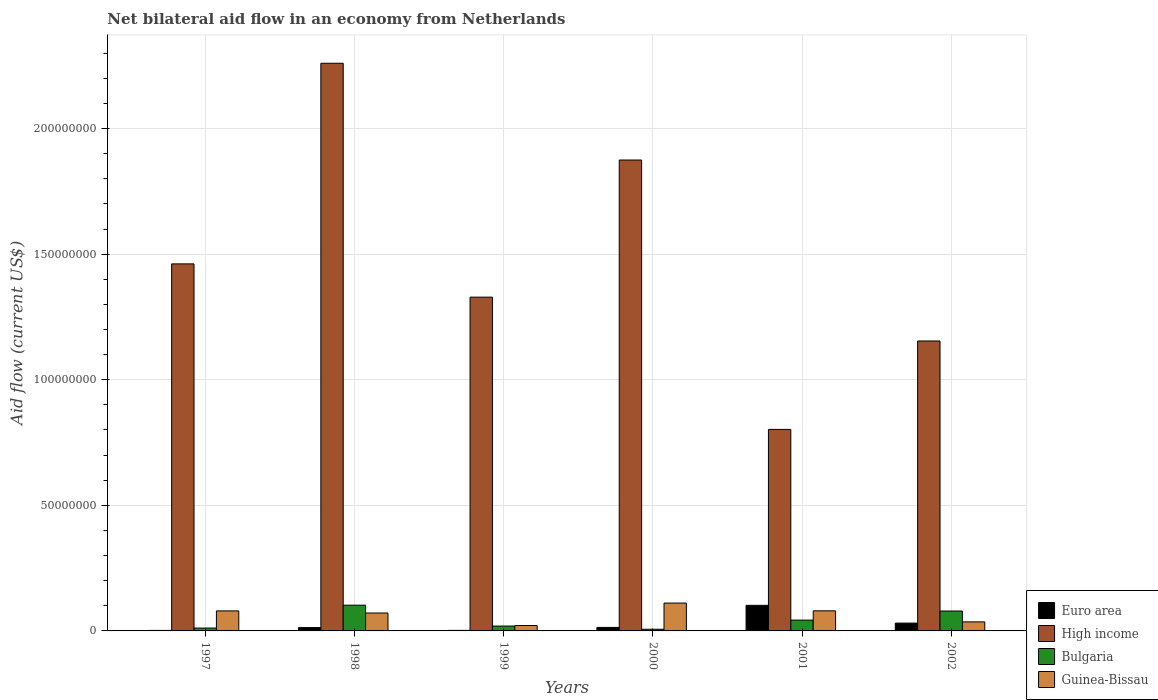How many different coloured bars are there?
Your answer should be compact. 4. How many groups of bars are there?
Provide a short and direct response. 6. Are the number of bars on each tick of the X-axis equal?
Your answer should be compact. Yes. What is the net bilateral aid flow in Bulgaria in 1997?
Your response must be concise. 1.14e+06. Across all years, what is the maximum net bilateral aid flow in Euro area?
Ensure brevity in your answer.  1.02e+07. Across all years, what is the minimum net bilateral aid flow in Euro area?
Your answer should be compact. 2.10e+05. In which year was the net bilateral aid flow in High income maximum?
Keep it short and to the point. 1998. In which year was the net bilateral aid flow in Bulgaria minimum?
Your response must be concise. 2000. What is the total net bilateral aid flow in Guinea-Bissau in the graph?
Provide a succinct answer. 3.99e+07. What is the difference between the net bilateral aid flow in Euro area in 1997 and that in 2001?
Provide a short and direct response. -9.98e+06. What is the difference between the net bilateral aid flow in Bulgaria in 1998 and the net bilateral aid flow in High income in 2002?
Give a very brief answer. -1.05e+08. What is the average net bilateral aid flow in Bulgaria per year?
Offer a terse response. 4.37e+06. In the year 2002, what is the difference between the net bilateral aid flow in Bulgaria and net bilateral aid flow in Euro area?
Make the answer very short. 4.81e+06. What is the ratio of the net bilateral aid flow in High income in 1998 to that in 2002?
Your response must be concise. 1.96. Is the net bilateral aid flow in Bulgaria in 1997 less than that in 2001?
Make the answer very short. Yes. What is the difference between the highest and the second highest net bilateral aid flow in Euro area?
Give a very brief answer. 7.08e+06. What is the difference between the highest and the lowest net bilateral aid flow in High income?
Make the answer very short. 1.46e+08. Is it the case that in every year, the sum of the net bilateral aid flow in Guinea-Bissau and net bilateral aid flow in High income is greater than the net bilateral aid flow in Euro area?
Provide a succinct answer. Yes. Are all the bars in the graph horizontal?
Provide a succinct answer. No. How many years are there in the graph?
Make the answer very short. 6. What is the difference between two consecutive major ticks on the Y-axis?
Your answer should be very brief. 5.00e+07. Does the graph contain any zero values?
Your answer should be very brief. No. How are the legend labels stacked?
Give a very brief answer. Vertical. What is the title of the graph?
Provide a short and direct response. Net bilateral aid flow in an economy from Netherlands. Does "Euro area" appear as one of the legend labels in the graph?
Your answer should be very brief. Yes. What is the label or title of the Y-axis?
Your answer should be compact. Aid flow (current US$). What is the Aid flow (current US$) of High income in 1997?
Your answer should be very brief. 1.46e+08. What is the Aid flow (current US$) of Bulgaria in 1997?
Provide a succinct answer. 1.14e+06. What is the Aid flow (current US$) of Guinea-Bissau in 1997?
Offer a terse response. 7.97e+06. What is the Aid flow (current US$) in Euro area in 1998?
Your answer should be compact. 1.33e+06. What is the Aid flow (current US$) of High income in 1998?
Offer a very short reply. 2.26e+08. What is the Aid flow (current US$) in Bulgaria in 1998?
Offer a terse response. 1.02e+07. What is the Aid flow (current US$) in Guinea-Bissau in 1998?
Provide a short and direct response. 7.13e+06. What is the Aid flow (current US$) of Euro area in 1999?
Your response must be concise. 2.20e+05. What is the Aid flow (current US$) in High income in 1999?
Your response must be concise. 1.33e+08. What is the Aid flow (current US$) in Bulgaria in 1999?
Your answer should be compact. 1.94e+06. What is the Aid flow (current US$) in Guinea-Bissau in 1999?
Ensure brevity in your answer.  2.15e+06. What is the Aid flow (current US$) in Euro area in 2000?
Your answer should be very brief. 1.40e+06. What is the Aid flow (current US$) in High income in 2000?
Make the answer very short. 1.87e+08. What is the Aid flow (current US$) of Bulgaria in 2000?
Provide a succinct answer. 6.70e+05. What is the Aid flow (current US$) of Guinea-Bissau in 2000?
Give a very brief answer. 1.11e+07. What is the Aid flow (current US$) of Euro area in 2001?
Give a very brief answer. 1.02e+07. What is the Aid flow (current US$) of High income in 2001?
Provide a short and direct response. 8.02e+07. What is the Aid flow (current US$) in Bulgaria in 2001?
Provide a short and direct response. 4.31e+06. What is the Aid flow (current US$) in Euro area in 2002?
Offer a terse response. 3.11e+06. What is the Aid flow (current US$) in High income in 2002?
Ensure brevity in your answer.  1.15e+08. What is the Aid flow (current US$) in Bulgaria in 2002?
Your answer should be compact. 7.92e+06. What is the Aid flow (current US$) in Guinea-Bissau in 2002?
Your answer should be very brief. 3.60e+06. Across all years, what is the maximum Aid flow (current US$) in Euro area?
Your answer should be compact. 1.02e+07. Across all years, what is the maximum Aid flow (current US$) in High income?
Give a very brief answer. 2.26e+08. Across all years, what is the maximum Aid flow (current US$) of Bulgaria?
Offer a very short reply. 1.02e+07. Across all years, what is the maximum Aid flow (current US$) of Guinea-Bissau?
Ensure brevity in your answer.  1.11e+07. Across all years, what is the minimum Aid flow (current US$) of Euro area?
Provide a short and direct response. 2.10e+05. Across all years, what is the minimum Aid flow (current US$) in High income?
Provide a short and direct response. 8.02e+07. Across all years, what is the minimum Aid flow (current US$) of Bulgaria?
Give a very brief answer. 6.70e+05. Across all years, what is the minimum Aid flow (current US$) of Guinea-Bissau?
Provide a short and direct response. 2.15e+06. What is the total Aid flow (current US$) in Euro area in the graph?
Offer a terse response. 1.65e+07. What is the total Aid flow (current US$) of High income in the graph?
Keep it short and to the point. 8.88e+08. What is the total Aid flow (current US$) in Bulgaria in the graph?
Make the answer very short. 2.62e+07. What is the total Aid flow (current US$) of Guinea-Bissau in the graph?
Keep it short and to the point. 3.99e+07. What is the difference between the Aid flow (current US$) in Euro area in 1997 and that in 1998?
Your response must be concise. -1.12e+06. What is the difference between the Aid flow (current US$) of High income in 1997 and that in 1998?
Your answer should be very brief. -7.99e+07. What is the difference between the Aid flow (current US$) in Bulgaria in 1997 and that in 1998?
Provide a succinct answer. -9.11e+06. What is the difference between the Aid flow (current US$) of Guinea-Bissau in 1997 and that in 1998?
Your answer should be compact. 8.40e+05. What is the difference between the Aid flow (current US$) in High income in 1997 and that in 1999?
Offer a terse response. 1.32e+07. What is the difference between the Aid flow (current US$) in Bulgaria in 1997 and that in 1999?
Ensure brevity in your answer.  -8.00e+05. What is the difference between the Aid flow (current US$) of Guinea-Bissau in 1997 and that in 1999?
Give a very brief answer. 5.82e+06. What is the difference between the Aid flow (current US$) of Euro area in 1997 and that in 2000?
Keep it short and to the point. -1.19e+06. What is the difference between the Aid flow (current US$) of High income in 1997 and that in 2000?
Your response must be concise. -4.14e+07. What is the difference between the Aid flow (current US$) in Guinea-Bissau in 1997 and that in 2000?
Offer a very short reply. -3.12e+06. What is the difference between the Aid flow (current US$) of Euro area in 1997 and that in 2001?
Ensure brevity in your answer.  -9.98e+06. What is the difference between the Aid flow (current US$) of High income in 1997 and that in 2001?
Your answer should be very brief. 6.59e+07. What is the difference between the Aid flow (current US$) in Bulgaria in 1997 and that in 2001?
Give a very brief answer. -3.17e+06. What is the difference between the Aid flow (current US$) of Euro area in 1997 and that in 2002?
Ensure brevity in your answer.  -2.90e+06. What is the difference between the Aid flow (current US$) of High income in 1997 and that in 2002?
Make the answer very short. 3.07e+07. What is the difference between the Aid flow (current US$) of Bulgaria in 1997 and that in 2002?
Your answer should be compact. -6.78e+06. What is the difference between the Aid flow (current US$) of Guinea-Bissau in 1997 and that in 2002?
Provide a succinct answer. 4.37e+06. What is the difference between the Aid flow (current US$) in Euro area in 1998 and that in 1999?
Provide a succinct answer. 1.11e+06. What is the difference between the Aid flow (current US$) in High income in 1998 and that in 1999?
Keep it short and to the point. 9.31e+07. What is the difference between the Aid flow (current US$) of Bulgaria in 1998 and that in 1999?
Your answer should be very brief. 8.31e+06. What is the difference between the Aid flow (current US$) in Guinea-Bissau in 1998 and that in 1999?
Your answer should be compact. 4.98e+06. What is the difference between the Aid flow (current US$) in Euro area in 1998 and that in 2000?
Keep it short and to the point. -7.00e+04. What is the difference between the Aid flow (current US$) in High income in 1998 and that in 2000?
Make the answer very short. 3.85e+07. What is the difference between the Aid flow (current US$) in Bulgaria in 1998 and that in 2000?
Provide a short and direct response. 9.58e+06. What is the difference between the Aid flow (current US$) of Guinea-Bissau in 1998 and that in 2000?
Your answer should be compact. -3.96e+06. What is the difference between the Aid flow (current US$) in Euro area in 1998 and that in 2001?
Your response must be concise. -8.86e+06. What is the difference between the Aid flow (current US$) in High income in 1998 and that in 2001?
Keep it short and to the point. 1.46e+08. What is the difference between the Aid flow (current US$) in Bulgaria in 1998 and that in 2001?
Your response must be concise. 5.94e+06. What is the difference between the Aid flow (current US$) in Guinea-Bissau in 1998 and that in 2001?
Offer a very short reply. -8.70e+05. What is the difference between the Aid flow (current US$) of Euro area in 1998 and that in 2002?
Offer a terse response. -1.78e+06. What is the difference between the Aid flow (current US$) in High income in 1998 and that in 2002?
Your response must be concise. 1.11e+08. What is the difference between the Aid flow (current US$) of Bulgaria in 1998 and that in 2002?
Provide a short and direct response. 2.33e+06. What is the difference between the Aid flow (current US$) in Guinea-Bissau in 1998 and that in 2002?
Keep it short and to the point. 3.53e+06. What is the difference between the Aid flow (current US$) in Euro area in 1999 and that in 2000?
Your answer should be very brief. -1.18e+06. What is the difference between the Aid flow (current US$) of High income in 1999 and that in 2000?
Your response must be concise. -5.46e+07. What is the difference between the Aid flow (current US$) of Bulgaria in 1999 and that in 2000?
Ensure brevity in your answer.  1.27e+06. What is the difference between the Aid flow (current US$) of Guinea-Bissau in 1999 and that in 2000?
Provide a succinct answer. -8.94e+06. What is the difference between the Aid flow (current US$) in Euro area in 1999 and that in 2001?
Your response must be concise. -9.97e+06. What is the difference between the Aid flow (current US$) of High income in 1999 and that in 2001?
Ensure brevity in your answer.  5.27e+07. What is the difference between the Aid flow (current US$) of Bulgaria in 1999 and that in 2001?
Provide a succinct answer. -2.37e+06. What is the difference between the Aid flow (current US$) of Guinea-Bissau in 1999 and that in 2001?
Give a very brief answer. -5.85e+06. What is the difference between the Aid flow (current US$) of Euro area in 1999 and that in 2002?
Ensure brevity in your answer.  -2.89e+06. What is the difference between the Aid flow (current US$) in High income in 1999 and that in 2002?
Offer a very short reply. 1.74e+07. What is the difference between the Aid flow (current US$) in Bulgaria in 1999 and that in 2002?
Make the answer very short. -5.98e+06. What is the difference between the Aid flow (current US$) of Guinea-Bissau in 1999 and that in 2002?
Give a very brief answer. -1.45e+06. What is the difference between the Aid flow (current US$) in Euro area in 2000 and that in 2001?
Offer a terse response. -8.79e+06. What is the difference between the Aid flow (current US$) in High income in 2000 and that in 2001?
Your answer should be compact. 1.07e+08. What is the difference between the Aid flow (current US$) in Bulgaria in 2000 and that in 2001?
Provide a short and direct response. -3.64e+06. What is the difference between the Aid flow (current US$) in Guinea-Bissau in 2000 and that in 2001?
Keep it short and to the point. 3.09e+06. What is the difference between the Aid flow (current US$) of Euro area in 2000 and that in 2002?
Your answer should be very brief. -1.71e+06. What is the difference between the Aid flow (current US$) in High income in 2000 and that in 2002?
Your answer should be compact. 7.20e+07. What is the difference between the Aid flow (current US$) in Bulgaria in 2000 and that in 2002?
Provide a short and direct response. -7.25e+06. What is the difference between the Aid flow (current US$) in Guinea-Bissau in 2000 and that in 2002?
Ensure brevity in your answer.  7.49e+06. What is the difference between the Aid flow (current US$) of Euro area in 2001 and that in 2002?
Keep it short and to the point. 7.08e+06. What is the difference between the Aid flow (current US$) of High income in 2001 and that in 2002?
Provide a short and direct response. -3.52e+07. What is the difference between the Aid flow (current US$) in Bulgaria in 2001 and that in 2002?
Your answer should be very brief. -3.61e+06. What is the difference between the Aid flow (current US$) in Guinea-Bissau in 2001 and that in 2002?
Make the answer very short. 4.40e+06. What is the difference between the Aid flow (current US$) of Euro area in 1997 and the Aid flow (current US$) of High income in 1998?
Offer a very short reply. -2.26e+08. What is the difference between the Aid flow (current US$) of Euro area in 1997 and the Aid flow (current US$) of Bulgaria in 1998?
Provide a short and direct response. -1.00e+07. What is the difference between the Aid flow (current US$) in Euro area in 1997 and the Aid flow (current US$) in Guinea-Bissau in 1998?
Keep it short and to the point. -6.92e+06. What is the difference between the Aid flow (current US$) in High income in 1997 and the Aid flow (current US$) in Bulgaria in 1998?
Make the answer very short. 1.36e+08. What is the difference between the Aid flow (current US$) of High income in 1997 and the Aid flow (current US$) of Guinea-Bissau in 1998?
Offer a very short reply. 1.39e+08. What is the difference between the Aid flow (current US$) of Bulgaria in 1997 and the Aid flow (current US$) of Guinea-Bissau in 1998?
Give a very brief answer. -5.99e+06. What is the difference between the Aid flow (current US$) of Euro area in 1997 and the Aid flow (current US$) of High income in 1999?
Provide a succinct answer. -1.33e+08. What is the difference between the Aid flow (current US$) in Euro area in 1997 and the Aid flow (current US$) in Bulgaria in 1999?
Your answer should be compact. -1.73e+06. What is the difference between the Aid flow (current US$) of Euro area in 1997 and the Aid flow (current US$) of Guinea-Bissau in 1999?
Keep it short and to the point. -1.94e+06. What is the difference between the Aid flow (current US$) of High income in 1997 and the Aid flow (current US$) of Bulgaria in 1999?
Your answer should be very brief. 1.44e+08. What is the difference between the Aid flow (current US$) of High income in 1997 and the Aid flow (current US$) of Guinea-Bissau in 1999?
Provide a short and direct response. 1.44e+08. What is the difference between the Aid flow (current US$) in Bulgaria in 1997 and the Aid flow (current US$) in Guinea-Bissau in 1999?
Your answer should be compact. -1.01e+06. What is the difference between the Aid flow (current US$) in Euro area in 1997 and the Aid flow (current US$) in High income in 2000?
Your answer should be very brief. -1.87e+08. What is the difference between the Aid flow (current US$) of Euro area in 1997 and the Aid flow (current US$) of Bulgaria in 2000?
Your answer should be compact. -4.60e+05. What is the difference between the Aid flow (current US$) of Euro area in 1997 and the Aid flow (current US$) of Guinea-Bissau in 2000?
Keep it short and to the point. -1.09e+07. What is the difference between the Aid flow (current US$) of High income in 1997 and the Aid flow (current US$) of Bulgaria in 2000?
Provide a short and direct response. 1.45e+08. What is the difference between the Aid flow (current US$) in High income in 1997 and the Aid flow (current US$) in Guinea-Bissau in 2000?
Your answer should be compact. 1.35e+08. What is the difference between the Aid flow (current US$) in Bulgaria in 1997 and the Aid flow (current US$) in Guinea-Bissau in 2000?
Make the answer very short. -9.95e+06. What is the difference between the Aid flow (current US$) of Euro area in 1997 and the Aid flow (current US$) of High income in 2001?
Make the answer very short. -8.00e+07. What is the difference between the Aid flow (current US$) of Euro area in 1997 and the Aid flow (current US$) of Bulgaria in 2001?
Your response must be concise. -4.10e+06. What is the difference between the Aid flow (current US$) of Euro area in 1997 and the Aid flow (current US$) of Guinea-Bissau in 2001?
Offer a very short reply. -7.79e+06. What is the difference between the Aid flow (current US$) of High income in 1997 and the Aid flow (current US$) of Bulgaria in 2001?
Your response must be concise. 1.42e+08. What is the difference between the Aid flow (current US$) in High income in 1997 and the Aid flow (current US$) in Guinea-Bissau in 2001?
Make the answer very short. 1.38e+08. What is the difference between the Aid flow (current US$) of Bulgaria in 1997 and the Aid flow (current US$) of Guinea-Bissau in 2001?
Provide a succinct answer. -6.86e+06. What is the difference between the Aid flow (current US$) in Euro area in 1997 and the Aid flow (current US$) in High income in 2002?
Provide a short and direct response. -1.15e+08. What is the difference between the Aid flow (current US$) of Euro area in 1997 and the Aid flow (current US$) of Bulgaria in 2002?
Keep it short and to the point. -7.71e+06. What is the difference between the Aid flow (current US$) of Euro area in 1997 and the Aid flow (current US$) of Guinea-Bissau in 2002?
Provide a short and direct response. -3.39e+06. What is the difference between the Aid flow (current US$) of High income in 1997 and the Aid flow (current US$) of Bulgaria in 2002?
Your answer should be very brief. 1.38e+08. What is the difference between the Aid flow (current US$) in High income in 1997 and the Aid flow (current US$) in Guinea-Bissau in 2002?
Your response must be concise. 1.43e+08. What is the difference between the Aid flow (current US$) in Bulgaria in 1997 and the Aid flow (current US$) in Guinea-Bissau in 2002?
Make the answer very short. -2.46e+06. What is the difference between the Aid flow (current US$) of Euro area in 1998 and the Aid flow (current US$) of High income in 1999?
Provide a succinct answer. -1.32e+08. What is the difference between the Aid flow (current US$) of Euro area in 1998 and the Aid flow (current US$) of Bulgaria in 1999?
Ensure brevity in your answer.  -6.10e+05. What is the difference between the Aid flow (current US$) of Euro area in 1998 and the Aid flow (current US$) of Guinea-Bissau in 1999?
Your answer should be compact. -8.20e+05. What is the difference between the Aid flow (current US$) of High income in 1998 and the Aid flow (current US$) of Bulgaria in 1999?
Provide a short and direct response. 2.24e+08. What is the difference between the Aid flow (current US$) in High income in 1998 and the Aid flow (current US$) in Guinea-Bissau in 1999?
Provide a short and direct response. 2.24e+08. What is the difference between the Aid flow (current US$) in Bulgaria in 1998 and the Aid flow (current US$) in Guinea-Bissau in 1999?
Keep it short and to the point. 8.10e+06. What is the difference between the Aid flow (current US$) of Euro area in 1998 and the Aid flow (current US$) of High income in 2000?
Give a very brief answer. -1.86e+08. What is the difference between the Aid flow (current US$) of Euro area in 1998 and the Aid flow (current US$) of Bulgaria in 2000?
Ensure brevity in your answer.  6.60e+05. What is the difference between the Aid flow (current US$) of Euro area in 1998 and the Aid flow (current US$) of Guinea-Bissau in 2000?
Give a very brief answer. -9.76e+06. What is the difference between the Aid flow (current US$) in High income in 1998 and the Aid flow (current US$) in Bulgaria in 2000?
Make the answer very short. 2.25e+08. What is the difference between the Aid flow (current US$) in High income in 1998 and the Aid flow (current US$) in Guinea-Bissau in 2000?
Provide a short and direct response. 2.15e+08. What is the difference between the Aid flow (current US$) of Bulgaria in 1998 and the Aid flow (current US$) of Guinea-Bissau in 2000?
Provide a short and direct response. -8.40e+05. What is the difference between the Aid flow (current US$) of Euro area in 1998 and the Aid flow (current US$) of High income in 2001?
Provide a succinct answer. -7.89e+07. What is the difference between the Aid flow (current US$) of Euro area in 1998 and the Aid flow (current US$) of Bulgaria in 2001?
Keep it short and to the point. -2.98e+06. What is the difference between the Aid flow (current US$) of Euro area in 1998 and the Aid flow (current US$) of Guinea-Bissau in 2001?
Make the answer very short. -6.67e+06. What is the difference between the Aid flow (current US$) of High income in 1998 and the Aid flow (current US$) of Bulgaria in 2001?
Provide a short and direct response. 2.22e+08. What is the difference between the Aid flow (current US$) in High income in 1998 and the Aid flow (current US$) in Guinea-Bissau in 2001?
Make the answer very short. 2.18e+08. What is the difference between the Aid flow (current US$) in Bulgaria in 1998 and the Aid flow (current US$) in Guinea-Bissau in 2001?
Offer a terse response. 2.25e+06. What is the difference between the Aid flow (current US$) in Euro area in 1998 and the Aid flow (current US$) in High income in 2002?
Make the answer very short. -1.14e+08. What is the difference between the Aid flow (current US$) of Euro area in 1998 and the Aid flow (current US$) of Bulgaria in 2002?
Offer a very short reply. -6.59e+06. What is the difference between the Aid flow (current US$) of Euro area in 1998 and the Aid flow (current US$) of Guinea-Bissau in 2002?
Keep it short and to the point. -2.27e+06. What is the difference between the Aid flow (current US$) of High income in 1998 and the Aid flow (current US$) of Bulgaria in 2002?
Your answer should be compact. 2.18e+08. What is the difference between the Aid flow (current US$) of High income in 1998 and the Aid flow (current US$) of Guinea-Bissau in 2002?
Your answer should be compact. 2.22e+08. What is the difference between the Aid flow (current US$) of Bulgaria in 1998 and the Aid flow (current US$) of Guinea-Bissau in 2002?
Provide a short and direct response. 6.65e+06. What is the difference between the Aid flow (current US$) of Euro area in 1999 and the Aid flow (current US$) of High income in 2000?
Keep it short and to the point. -1.87e+08. What is the difference between the Aid flow (current US$) of Euro area in 1999 and the Aid flow (current US$) of Bulgaria in 2000?
Offer a very short reply. -4.50e+05. What is the difference between the Aid flow (current US$) of Euro area in 1999 and the Aid flow (current US$) of Guinea-Bissau in 2000?
Your answer should be compact. -1.09e+07. What is the difference between the Aid flow (current US$) in High income in 1999 and the Aid flow (current US$) in Bulgaria in 2000?
Keep it short and to the point. 1.32e+08. What is the difference between the Aid flow (current US$) in High income in 1999 and the Aid flow (current US$) in Guinea-Bissau in 2000?
Offer a very short reply. 1.22e+08. What is the difference between the Aid flow (current US$) in Bulgaria in 1999 and the Aid flow (current US$) in Guinea-Bissau in 2000?
Give a very brief answer. -9.15e+06. What is the difference between the Aid flow (current US$) of Euro area in 1999 and the Aid flow (current US$) of High income in 2001?
Your answer should be compact. -8.00e+07. What is the difference between the Aid flow (current US$) in Euro area in 1999 and the Aid flow (current US$) in Bulgaria in 2001?
Offer a very short reply. -4.09e+06. What is the difference between the Aid flow (current US$) in Euro area in 1999 and the Aid flow (current US$) in Guinea-Bissau in 2001?
Keep it short and to the point. -7.78e+06. What is the difference between the Aid flow (current US$) in High income in 1999 and the Aid flow (current US$) in Bulgaria in 2001?
Ensure brevity in your answer.  1.29e+08. What is the difference between the Aid flow (current US$) of High income in 1999 and the Aid flow (current US$) of Guinea-Bissau in 2001?
Make the answer very short. 1.25e+08. What is the difference between the Aid flow (current US$) in Bulgaria in 1999 and the Aid flow (current US$) in Guinea-Bissau in 2001?
Keep it short and to the point. -6.06e+06. What is the difference between the Aid flow (current US$) in Euro area in 1999 and the Aid flow (current US$) in High income in 2002?
Provide a succinct answer. -1.15e+08. What is the difference between the Aid flow (current US$) of Euro area in 1999 and the Aid flow (current US$) of Bulgaria in 2002?
Offer a terse response. -7.70e+06. What is the difference between the Aid flow (current US$) of Euro area in 1999 and the Aid flow (current US$) of Guinea-Bissau in 2002?
Keep it short and to the point. -3.38e+06. What is the difference between the Aid flow (current US$) of High income in 1999 and the Aid flow (current US$) of Bulgaria in 2002?
Give a very brief answer. 1.25e+08. What is the difference between the Aid flow (current US$) of High income in 1999 and the Aid flow (current US$) of Guinea-Bissau in 2002?
Ensure brevity in your answer.  1.29e+08. What is the difference between the Aid flow (current US$) of Bulgaria in 1999 and the Aid flow (current US$) of Guinea-Bissau in 2002?
Offer a very short reply. -1.66e+06. What is the difference between the Aid flow (current US$) in Euro area in 2000 and the Aid flow (current US$) in High income in 2001?
Make the answer very short. -7.88e+07. What is the difference between the Aid flow (current US$) of Euro area in 2000 and the Aid flow (current US$) of Bulgaria in 2001?
Keep it short and to the point. -2.91e+06. What is the difference between the Aid flow (current US$) of Euro area in 2000 and the Aid flow (current US$) of Guinea-Bissau in 2001?
Keep it short and to the point. -6.60e+06. What is the difference between the Aid flow (current US$) of High income in 2000 and the Aid flow (current US$) of Bulgaria in 2001?
Provide a succinct answer. 1.83e+08. What is the difference between the Aid flow (current US$) in High income in 2000 and the Aid flow (current US$) in Guinea-Bissau in 2001?
Offer a very short reply. 1.79e+08. What is the difference between the Aid flow (current US$) in Bulgaria in 2000 and the Aid flow (current US$) in Guinea-Bissau in 2001?
Ensure brevity in your answer.  -7.33e+06. What is the difference between the Aid flow (current US$) of Euro area in 2000 and the Aid flow (current US$) of High income in 2002?
Make the answer very short. -1.14e+08. What is the difference between the Aid flow (current US$) of Euro area in 2000 and the Aid flow (current US$) of Bulgaria in 2002?
Keep it short and to the point. -6.52e+06. What is the difference between the Aid flow (current US$) in Euro area in 2000 and the Aid flow (current US$) in Guinea-Bissau in 2002?
Ensure brevity in your answer.  -2.20e+06. What is the difference between the Aid flow (current US$) in High income in 2000 and the Aid flow (current US$) in Bulgaria in 2002?
Make the answer very short. 1.80e+08. What is the difference between the Aid flow (current US$) of High income in 2000 and the Aid flow (current US$) of Guinea-Bissau in 2002?
Your answer should be compact. 1.84e+08. What is the difference between the Aid flow (current US$) of Bulgaria in 2000 and the Aid flow (current US$) of Guinea-Bissau in 2002?
Ensure brevity in your answer.  -2.93e+06. What is the difference between the Aid flow (current US$) of Euro area in 2001 and the Aid flow (current US$) of High income in 2002?
Make the answer very short. -1.05e+08. What is the difference between the Aid flow (current US$) in Euro area in 2001 and the Aid flow (current US$) in Bulgaria in 2002?
Make the answer very short. 2.27e+06. What is the difference between the Aid flow (current US$) in Euro area in 2001 and the Aid flow (current US$) in Guinea-Bissau in 2002?
Offer a very short reply. 6.59e+06. What is the difference between the Aid flow (current US$) of High income in 2001 and the Aid flow (current US$) of Bulgaria in 2002?
Your answer should be compact. 7.23e+07. What is the difference between the Aid flow (current US$) of High income in 2001 and the Aid flow (current US$) of Guinea-Bissau in 2002?
Give a very brief answer. 7.66e+07. What is the difference between the Aid flow (current US$) of Bulgaria in 2001 and the Aid flow (current US$) of Guinea-Bissau in 2002?
Give a very brief answer. 7.10e+05. What is the average Aid flow (current US$) in Euro area per year?
Make the answer very short. 2.74e+06. What is the average Aid flow (current US$) of High income per year?
Ensure brevity in your answer.  1.48e+08. What is the average Aid flow (current US$) of Bulgaria per year?
Keep it short and to the point. 4.37e+06. What is the average Aid flow (current US$) in Guinea-Bissau per year?
Give a very brief answer. 6.66e+06. In the year 1997, what is the difference between the Aid flow (current US$) of Euro area and Aid flow (current US$) of High income?
Offer a very short reply. -1.46e+08. In the year 1997, what is the difference between the Aid flow (current US$) of Euro area and Aid flow (current US$) of Bulgaria?
Your answer should be compact. -9.30e+05. In the year 1997, what is the difference between the Aid flow (current US$) of Euro area and Aid flow (current US$) of Guinea-Bissau?
Your response must be concise. -7.76e+06. In the year 1997, what is the difference between the Aid flow (current US$) of High income and Aid flow (current US$) of Bulgaria?
Make the answer very short. 1.45e+08. In the year 1997, what is the difference between the Aid flow (current US$) of High income and Aid flow (current US$) of Guinea-Bissau?
Offer a terse response. 1.38e+08. In the year 1997, what is the difference between the Aid flow (current US$) of Bulgaria and Aid flow (current US$) of Guinea-Bissau?
Give a very brief answer. -6.83e+06. In the year 1998, what is the difference between the Aid flow (current US$) in Euro area and Aid flow (current US$) in High income?
Provide a short and direct response. -2.25e+08. In the year 1998, what is the difference between the Aid flow (current US$) in Euro area and Aid flow (current US$) in Bulgaria?
Offer a very short reply. -8.92e+06. In the year 1998, what is the difference between the Aid flow (current US$) in Euro area and Aid flow (current US$) in Guinea-Bissau?
Your response must be concise. -5.80e+06. In the year 1998, what is the difference between the Aid flow (current US$) of High income and Aid flow (current US$) of Bulgaria?
Make the answer very short. 2.16e+08. In the year 1998, what is the difference between the Aid flow (current US$) of High income and Aid flow (current US$) of Guinea-Bissau?
Offer a very short reply. 2.19e+08. In the year 1998, what is the difference between the Aid flow (current US$) in Bulgaria and Aid flow (current US$) in Guinea-Bissau?
Your response must be concise. 3.12e+06. In the year 1999, what is the difference between the Aid flow (current US$) of Euro area and Aid flow (current US$) of High income?
Keep it short and to the point. -1.33e+08. In the year 1999, what is the difference between the Aid flow (current US$) in Euro area and Aid flow (current US$) in Bulgaria?
Your answer should be compact. -1.72e+06. In the year 1999, what is the difference between the Aid flow (current US$) in Euro area and Aid flow (current US$) in Guinea-Bissau?
Your response must be concise. -1.93e+06. In the year 1999, what is the difference between the Aid flow (current US$) in High income and Aid flow (current US$) in Bulgaria?
Your response must be concise. 1.31e+08. In the year 1999, what is the difference between the Aid flow (current US$) of High income and Aid flow (current US$) of Guinea-Bissau?
Offer a terse response. 1.31e+08. In the year 1999, what is the difference between the Aid flow (current US$) in Bulgaria and Aid flow (current US$) in Guinea-Bissau?
Offer a very short reply. -2.10e+05. In the year 2000, what is the difference between the Aid flow (current US$) of Euro area and Aid flow (current US$) of High income?
Provide a succinct answer. -1.86e+08. In the year 2000, what is the difference between the Aid flow (current US$) of Euro area and Aid flow (current US$) of Bulgaria?
Offer a very short reply. 7.30e+05. In the year 2000, what is the difference between the Aid flow (current US$) in Euro area and Aid flow (current US$) in Guinea-Bissau?
Ensure brevity in your answer.  -9.69e+06. In the year 2000, what is the difference between the Aid flow (current US$) of High income and Aid flow (current US$) of Bulgaria?
Ensure brevity in your answer.  1.87e+08. In the year 2000, what is the difference between the Aid flow (current US$) in High income and Aid flow (current US$) in Guinea-Bissau?
Provide a short and direct response. 1.76e+08. In the year 2000, what is the difference between the Aid flow (current US$) of Bulgaria and Aid flow (current US$) of Guinea-Bissau?
Ensure brevity in your answer.  -1.04e+07. In the year 2001, what is the difference between the Aid flow (current US$) of Euro area and Aid flow (current US$) of High income?
Provide a succinct answer. -7.00e+07. In the year 2001, what is the difference between the Aid flow (current US$) of Euro area and Aid flow (current US$) of Bulgaria?
Give a very brief answer. 5.88e+06. In the year 2001, what is the difference between the Aid flow (current US$) of Euro area and Aid flow (current US$) of Guinea-Bissau?
Your answer should be compact. 2.19e+06. In the year 2001, what is the difference between the Aid flow (current US$) of High income and Aid flow (current US$) of Bulgaria?
Keep it short and to the point. 7.59e+07. In the year 2001, what is the difference between the Aid flow (current US$) in High income and Aid flow (current US$) in Guinea-Bissau?
Provide a short and direct response. 7.22e+07. In the year 2001, what is the difference between the Aid flow (current US$) in Bulgaria and Aid flow (current US$) in Guinea-Bissau?
Your answer should be compact. -3.69e+06. In the year 2002, what is the difference between the Aid flow (current US$) of Euro area and Aid flow (current US$) of High income?
Your response must be concise. -1.12e+08. In the year 2002, what is the difference between the Aid flow (current US$) of Euro area and Aid flow (current US$) of Bulgaria?
Ensure brevity in your answer.  -4.81e+06. In the year 2002, what is the difference between the Aid flow (current US$) of Euro area and Aid flow (current US$) of Guinea-Bissau?
Offer a terse response. -4.90e+05. In the year 2002, what is the difference between the Aid flow (current US$) of High income and Aid flow (current US$) of Bulgaria?
Offer a very short reply. 1.08e+08. In the year 2002, what is the difference between the Aid flow (current US$) in High income and Aid flow (current US$) in Guinea-Bissau?
Your response must be concise. 1.12e+08. In the year 2002, what is the difference between the Aid flow (current US$) in Bulgaria and Aid flow (current US$) in Guinea-Bissau?
Make the answer very short. 4.32e+06. What is the ratio of the Aid flow (current US$) of Euro area in 1997 to that in 1998?
Offer a terse response. 0.16. What is the ratio of the Aid flow (current US$) of High income in 1997 to that in 1998?
Offer a very short reply. 0.65. What is the ratio of the Aid flow (current US$) in Bulgaria in 1997 to that in 1998?
Provide a succinct answer. 0.11. What is the ratio of the Aid flow (current US$) in Guinea-Bissau in 1997 to that in 1998?
Make the answer very short. 1.12. What is the ratio of the Aid flow (current US$) in Euro area in 1997 to that in 1999?
Offer a terse response. 0.95. What is the ratio of the Aid flow (current US$) in High income in 1997 to that in 1999?
Provide a short and direct response. 1.1. What is the ratio of the Aid flow (current US$) of Bulgaria in 1997 to that in 1999?
Your answer should be very brief. 0.59. What is the ratio of the Aid flow (current US$) in Guinea-Bissau in 1997 to that in 1999?
Your answer should be compact. 3.71. What is the ratio of the Aid flow (current US$) in High income in 1997 to that in 2000?
Provide a short and direct response. 0.78. What is the ratio of the Aid flow (current US$) in Bulgaria in 1997 to that in 2000?
Give a very brief answer. 1.7. What is the ratio of the Aid flow (current US$) of Guinea-Bissau in 1997 to that in 2000?
Ensure brevity in your answer.  0.72. What is the ratio of the Aid flow (current US$) in Euro area in 1997 to that in 2001?
Your response must be concise. 0.02. What is the ratio of the Aid flow (current US$) in High income in 1997 to that in 2001?
Offer a very short reply. 1.82. What is the ratio of the Aid flow (current US$) of Bulgaria in 1997 to that in 2001?
Ensure brevity in your answer.  0.26. What is the ratio of the Aid flow (current US$) of Guinea-Bissau in 1997 to that in 2001?
Provide a short and direct response. 1. What is the ratio of the Aid flow (current US$) of Euro area in 1997 to that in 2002?
Make the answer very short. 0.07. What is the ratio of the Aid flow (current US$) of High income in 1997 to that in 2002?
Make the answer very short. 1.27. What is the ratio of the Aid flow (current US$) of Bulgaria in 1997 to that in 2002?
Provide a short and direct response. 0.14. What is the ratio of the Aid flow (current US$) in Guinea-Bissau in 1997 to that in 2002?
Give a very brief answer. 2.21. What is the ratio of the Aid flow (current US$) of Euro area in 1998 to that in 1999?
Keep it short and to the point. 6.05. What is the ratio of the Aid flow (current US$) in High income in 1998 to that in 1999?
Provide a short and direct response. 1.7. What is the ratio of the Aid flow (current US$) of Bulgaria in 1998 to that in 1999?
Provide a short and direct response. 5.28. What is the ratio of the Aid flow (current US$) of Guinea-Bissau in 1998 to that in 1999?
Offer a terse response. 3.32. What is the ratio of the Aid flow (current US$) of Euro area in 1998 to that in 2000?
Keep it short and to the point. 0.95. What is the ratio of the Aid flow (current US$) of High income in 1998 to that in 2000?
Keep it short and to the point. 1.21. What is the ratio of the Aid flow (current US$) of Bulgaria in 1998 to that in 2000?
Give a very brief answer. 15.3. What is the ratio of the Aid flow (current US$) in Guinea-Bissau in 1998 to that in 2000?
Your answer should be very brief. 0.64. What is the ratio of the Aid flow (current US$) in Euro area in 1998 to that in 2001?
Offer a terse response. 0.13. What is the ratio of the Aid flow (current US$) in High income in 1998 to that in 2001?
Give a very brief answer. 2.82. What is the ratio of the Aid flow (current US$) in Bulgaria in 1998 to that in 2001?
Provide a succinct answer. 2.38. What is the ratio of the Aid flow (current US$) of Guinea-Bissau in 1998 to that in 2001?
Provide a succinct answer. 0.89. What is the ratio of the Aid flow (current US$) in Euro area in 1998 to that in 2002?
Provide a succinct answer. 0.43. What is the ratio of the Aid flow (current US$) of High income in 1998 to that in 2002?
Give a very brief answer. 1.96. What is the ratio of the Aid flow (current US$) of Bulgaria in 1998 to that in 2002?
Your answer should be compact. 1.29. What is the ratio of the Aid flow (current US$) in Guinea-Bissau in 1998 to that in 2002?
Make the answer very short. 1.98. What is the ratio of the Aid flow (current US$) of Euro area in 1999 to that in 2000?
Make the answer very short. 0.16. What is the ratio of the Aid flow (current US$) in High income in 1999 to that in 2000?
Provide a short and direct response. 0.71. What is the ratio of the Aid flow (current US$) in Bulgaria in 1999 to that in 2000?
Offer a very short reply. 2.9. What is the ratio of the Aid flow (current US$) in Guinea-Bissau in 1999 to that in 2000?
Your response must be concise. 0.19. What is the ratio of the Aid flow (current US$) of Euro area in 1999 to that in 2001?
Ensure brevity in your answer.  0.02. What is the ratio of the Aid flow (current US$) in High income in 1999 to that in 2001?
Offer a very short reply. 1.66. What is the ratio of the Aid flow (current US$) in Bulgaria in 1999 to that in 2001?
Make the answer very short. 0.45. What is the ratio of the Aid flow (current US$) of Guinea-Bissau in 1999 to that in 2001?
Keep it short and to the point. 0.27. What is the ratio of the Aid flow (current US$) of Euro area in 1999 to that in 2002?
Keep it short and to the point. 0.07. What is the ratio of the Aid flow (current US$) of High income in 1999 to that in 2002?
Offer a very short reply. 1.15. What is the ratio of the Aid flow (current US$) in Bulgaria in 1999 to that in 2002?
Offer a terse response. 0.24. What is the ratio of the Aid flow (current US$) of Guinea-Bissau in 1999 to that in 2002?
Your answer should be very brief. 0.6. What is the ratio of the Aid flow (current US$) in Euro area in 2000 to that in 2001?
Offer a terse response. 0.14. What is the ratio of the Aid flow (current US$) of High income in 2000 to that in 2001?
Give a very brief answer. 2.34. What is the ratio of the Aid flow (current US$) in Bulgaria in 2000 to that in 2001?
Your answer should be compact. 0.16. What is the ratio of the Aid flow (current US$) of Guinea-Bissau in 2000 to that in 2001?
Ensure brevity in your answer.  1.39. What is the ratio of the Aid flow (current US$) in Euro area in 2000 to that in 2002?
Your answer should be compact. 0.45. What is the ratio of the Aid flow (current US$) of High income in 2000 to that in 2002?
Provide a short and direct response. 1.62. What is the ratio of the Aid flow (current US$) of Bulgaria in 2000 to that in 2002?
Give a very brief answer. 0.08. What is the ratio of the Aid flow (current US$) of Guinea-Bissau in 2000 to that in 2002?
Ensure brevity in your answer.  3.08. What is the ratio of the Aid flow (current US$) in Euro area in 2001 to that in 2002?
Keep it short and to the point. 3.28. What is the ratio of the Aid flow (current US$) of High income in 2001 to that in 2002?
Provide a succinct answer. 0.69. What is the ratio of the Aid flow (current US$) of Bulgaria in 2001 to that in 2002?
Make the answer very short. 0.54. What is the ratio of the Aid flow (current US$) in Guinea-Bissau in 2001 to that in 2002?
Give a very brief answer. 2.22. What is the difference between the highest and the second highest Aid flow (current US$) in Euro area?
Your answer should be very brief. 7.08e+06. What is the difference between the highest and the second highest Aid flow (current US$) of High income?
Your answer should be compact. 3.85e+07. What is the difference between the highest and the second highest Aid flow (current US$) of Bulgaria?
Provide a succinct answer. 2.33e+06. What is the difference between the highest and the second highest Aid flow (current US$) in Guinea-Bissau?
Provide a short and direct response. 3.09e+06. What is the difference between the highest and the lowest Aid flow (current US$) of Euro area?
Provide a succinct answer. 9.98e+06. What is the difference between the highest and the lowest Aid flow (current US$) of High income?
Keep it short and to the point. 1.46e+08. What is the difference between the highest and the lowest Aid flow (current US$) of Bulgaria?
Provide a succinct answer. 9.58e+06. What is the difference between the highest and the lowest Aid flow (current US$) in Guinea-Bissau?
Provide a succinct answer. 8.94e+06. 